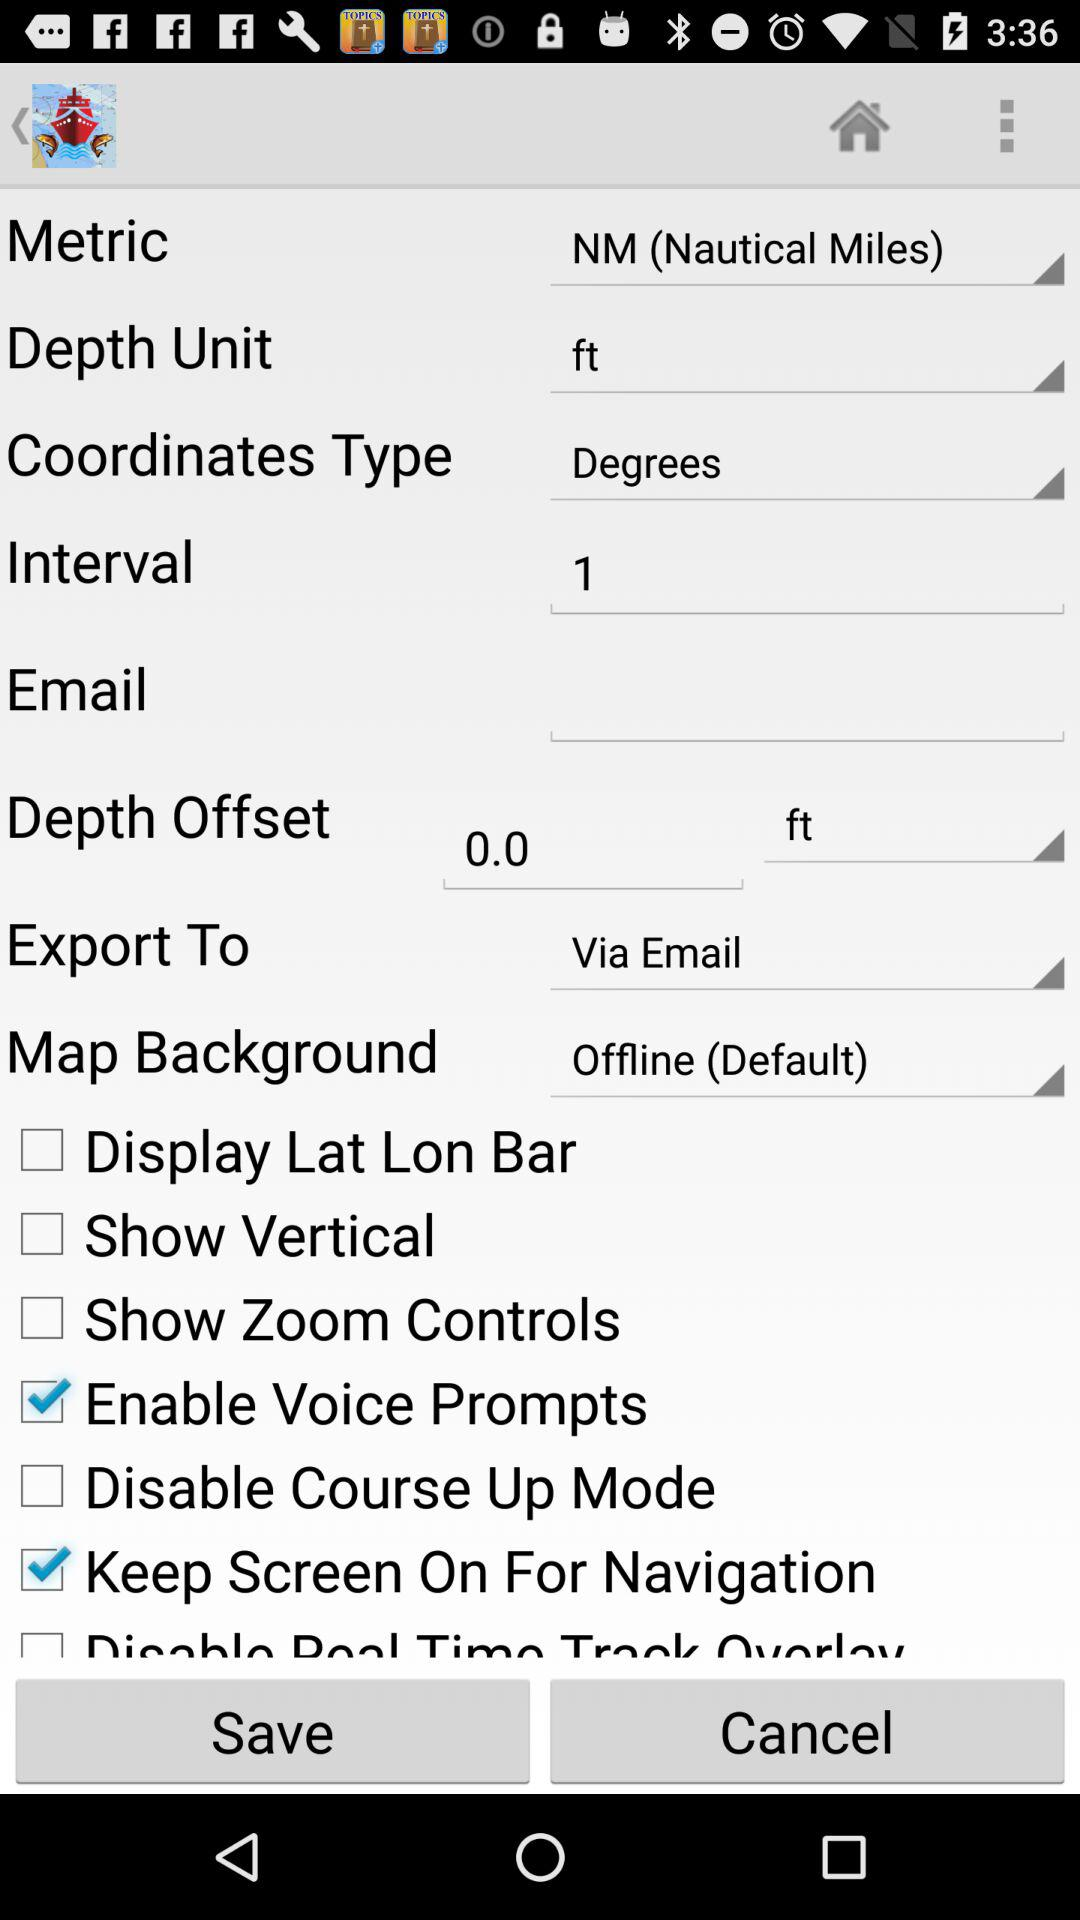What is the value of the interval? The value of the interval is 1. 